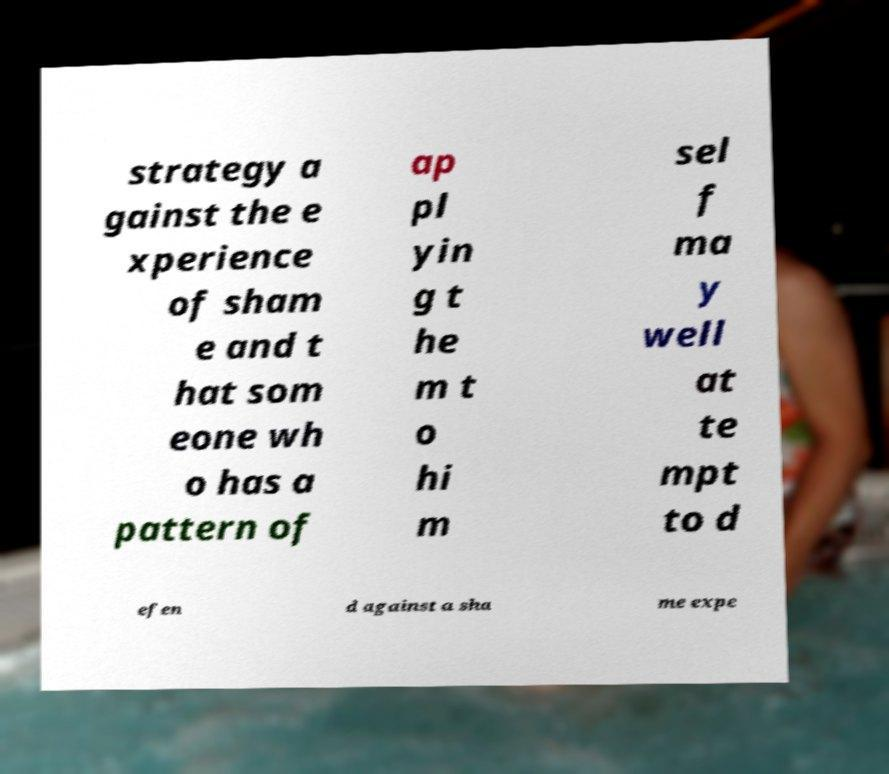Please read and relay the text visible in this image. What does it say? strategy a gainst the e xperience of sham e and t hat som eone wh o has a pattern of ap pl yin g t he m t o hi m sel f ma y well at te mpt to d efen d against a sha me expe 